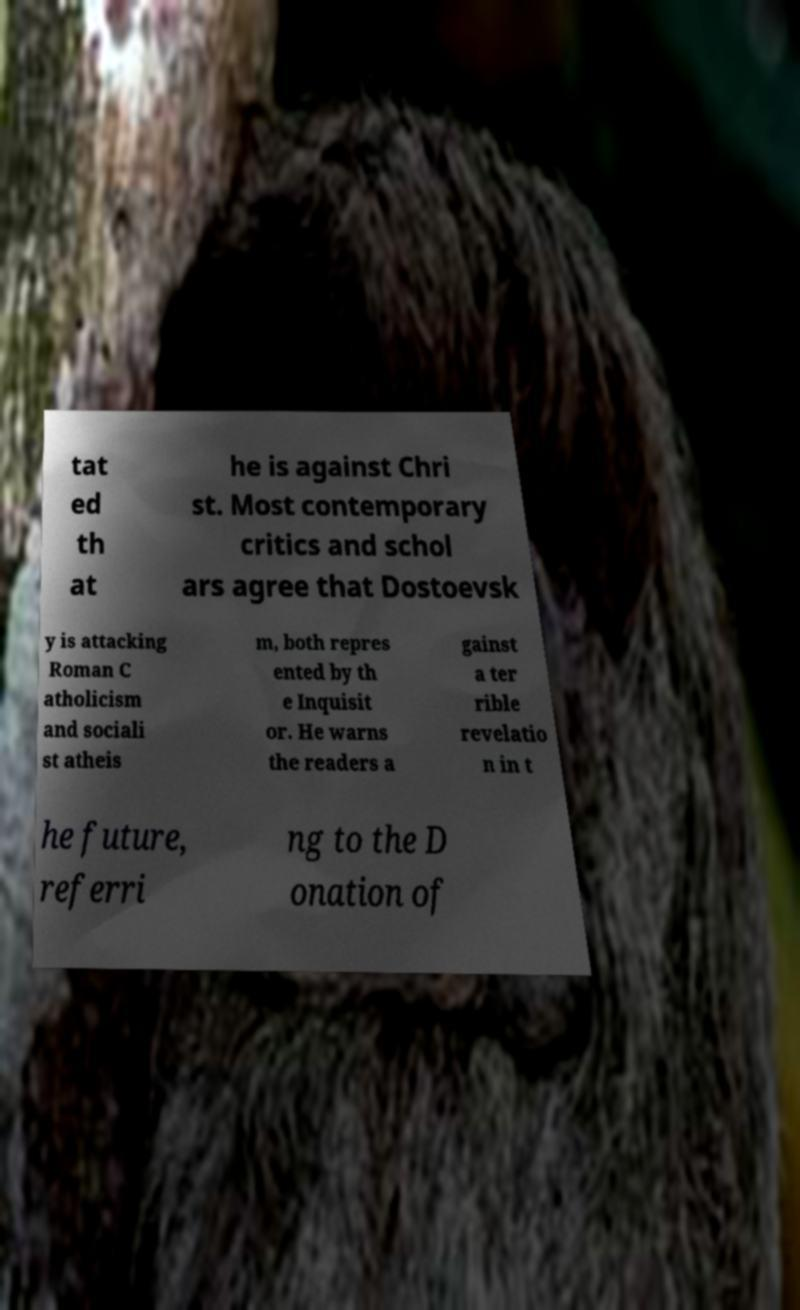Can you accurately transcribe the text from the provided image for me? tat ed th at he is against Chri st. Most contemporary critics and schol ars agree that Dostoevsk y is attacking Roman C atholicism and sociali st atheis m, both repres ented by th e Inquisit or. He warns the readers a gainst a ter rible revelatio n in t he future, referri ng to the D onation of 